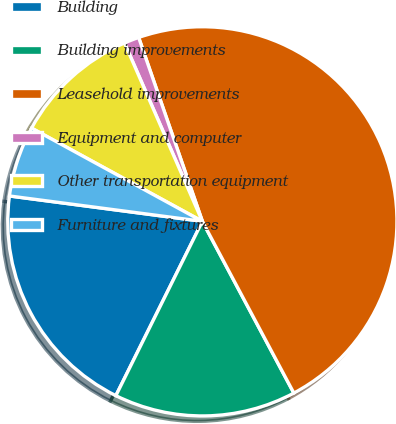Convert chart. <chart><loc_0><loc_0><loc_500><loc_500><pie_chart><fcel>Building<fcel>Building improvements<fcel>Leasehold improvements<fcel>Equipment and computer<fcel>Other transportation equipment<fcel>Furniture and fixtures<nl><fcel>19.75%<fcel>15.12%<fcel>47.52%<fcel>1.24%<fcel>10.5%<fcel>5.87%<nl></chart> 